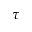<formula> <loc_0><loc_0><loc_500><loc_500>\tau</formula> 